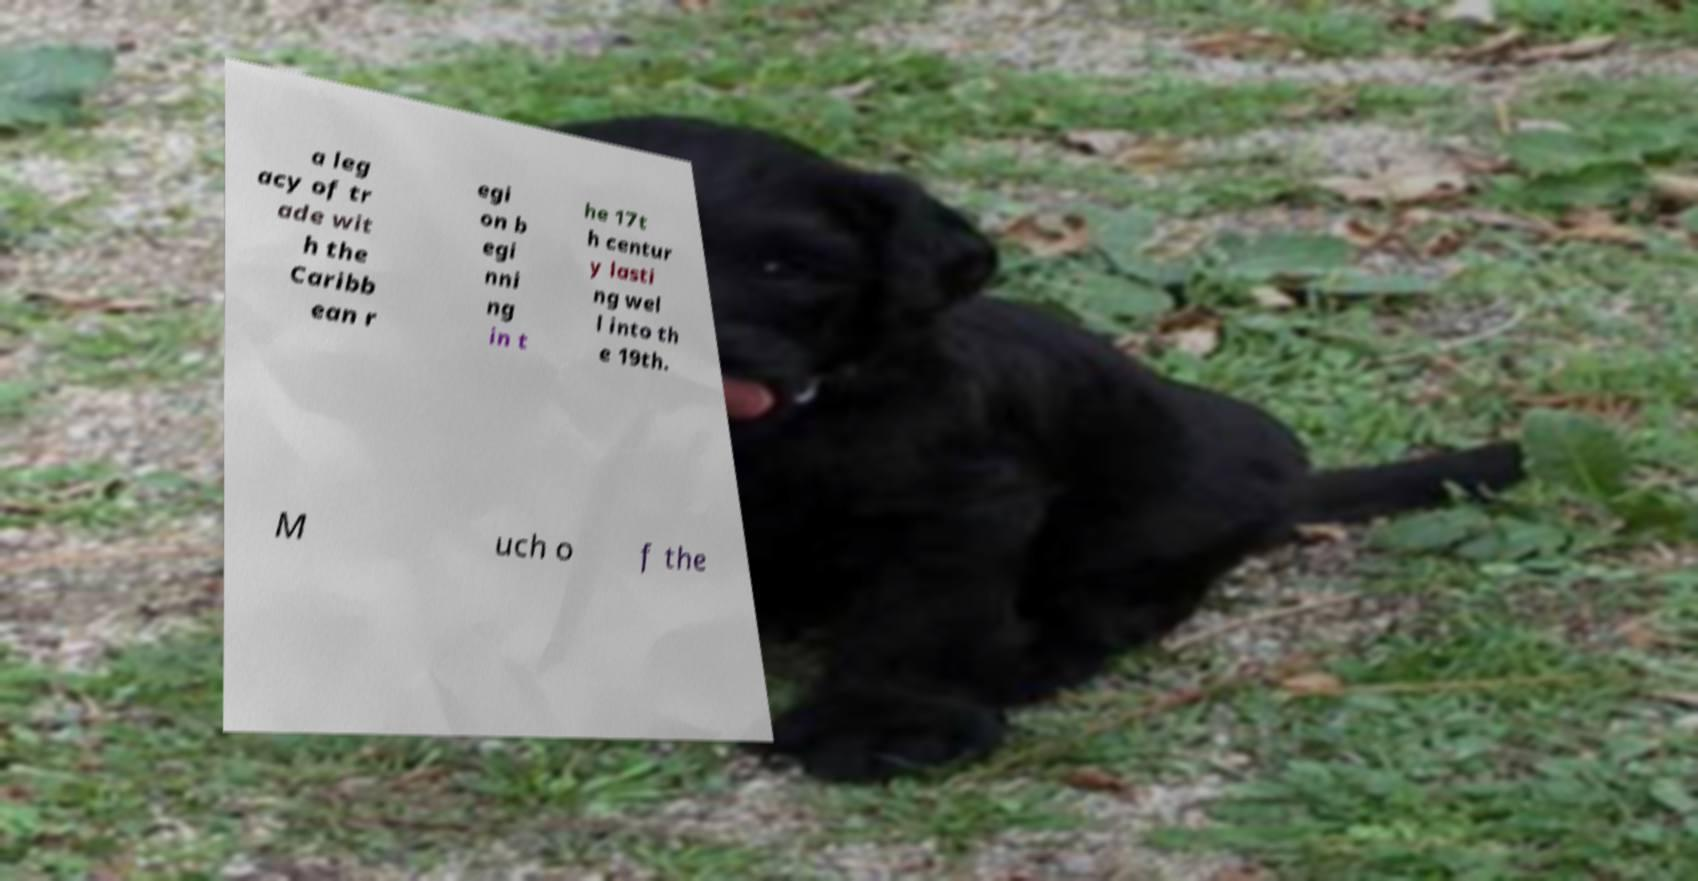Could you assist in decoding the text presented in this image and type it out clearly? a leg acy of tr ade wit h the Caribb ean r egi on b egi nni ng in t he 17t h centur y lasti ng wel l into th e 19th. M uch o f the 